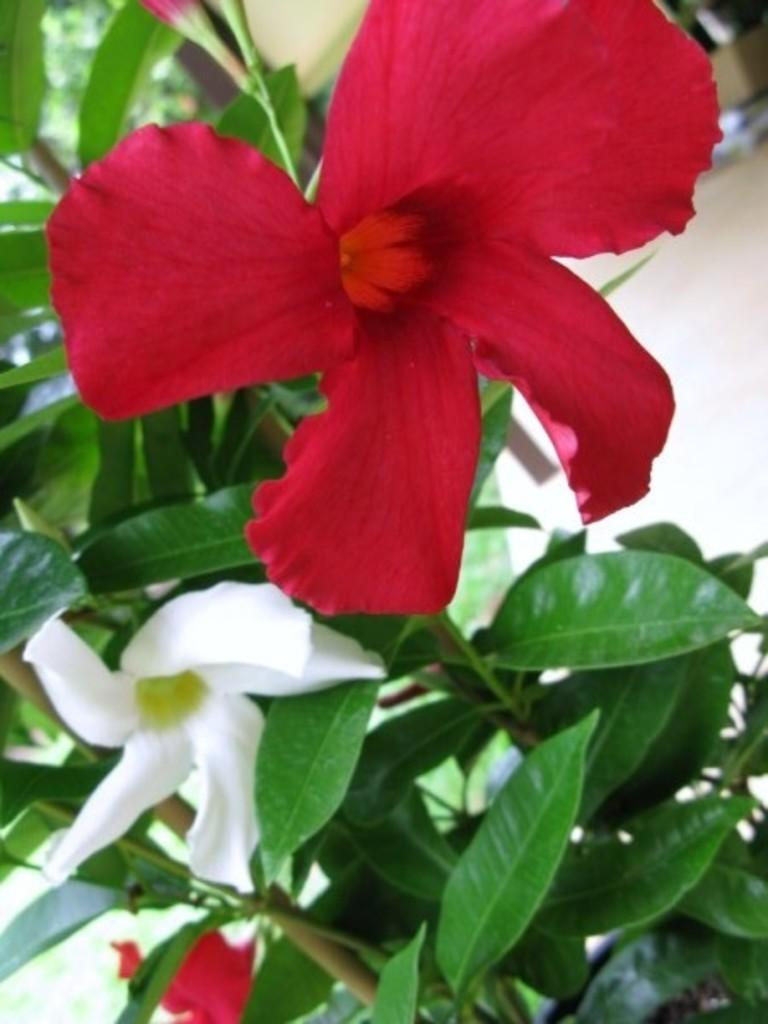What colors are the flowers in the image? There is a red flower and a white flower in the image. What can be seen on the left side of the flowers? There are green leaves on the left side of the flowers. What type of pan is being used to cook the flowers in the image? There is no pan or cooking activity present in the image; it features flowers and leaves. What authority figure can be seen overseeing the growth of the flowers in the image? There is no authority figure present in the image; it only shows flowers and leaves. 